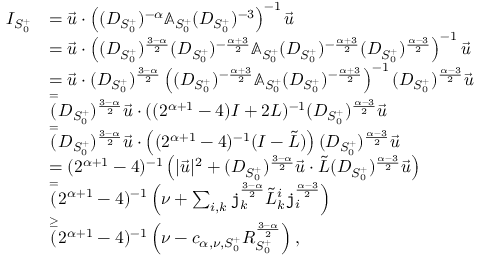<formula> <loc_0><loc_0><loc_500><loc_500>\begin{array} { r l } { I _ { S _ { 0 } ^ { + } } } & { = \vec { u } \cdot \left ( ( D _ { S _ { 0 } ^ { + } } ) ^ { - \alpha } \mathbb { A } _ { S _ { 0 } ^ { + } } ( D _ { S _ { 0 } ^ { + } } ) ^ { - 3 } \right ) ^ { - 1 } \vec { u } } \\ & { = \vec { u } \cdot \left ( ( D _ { S _ { 0 } ^ { + } } ) ^ { \frac { 3 - \alpha } 2 } ( D _ { S _ { 0 } ^ { + } } ) ^ { - \frac { \alpha + 3 } { 2 } } \mathbb { A } _ { S _ { 0 } ^ { + } } ( D _ { S _ { 0 } ^ { + } } ) ^ { - \frac { \alpha + 3 } 2 } ( D _ { S _ { 0 } ^ { + } } ) ^ { \frac { \alpha - 3 } 2 } \right ) ^ { - 1 } \vec { u } } \\ & { = \vec { u } \cdot ( D _ { S _ { 0 } ^ { + } } ) ^ { \frac { 3 - \alpha } 2 } \left ( ( D _ { S _ { 0 } ^ { + } } ) ^ { - \frac { \alpha + 3 } { 2 } } \mathbb { A } _ { S _ { 0 } ^ { + } } ( D _ { S _ { 0 } ^ { + } } ) ^ { - \frac { \alpha + 3 } 2 } \right ) ^ { - 1 } ( D _ { S _ { 0 } ^ { + } } ) ^ { \frac { \alpha - 3 } 2 } \vec { u } } \\ & { \overset { = } { ( } D _ { S _ { 0 } ^ { + } } ) ^ { \frac { 3 - \alpha } 2 } \vec { u } \cdot ( ( 2 ^ { \alpha + 1 } - 4 ) I + 2 L ) ^ { - 1 } ( D _ { S _ { 0 } ^ { + } } ) ^ { \frac { \alpha - 3 } 2 } \vec { u } } \\ & { \overset { = } { ( } D _ { S _ { 0 } ^ { + } } ) ^ { \frac { 3 - \alpha } 2 } \vec { u } \cdot \left ( ( 2 ^ { \alpha + 1 } - 4 ) ^ { - 1 } ( I - \tilde { L } ) \right ) ( D _ { S _ { 0 } ^ { + } } ) ^ { \frac { \alpha - 3 } 2 } \vec { u } } \\ & { = ( 2 ^ { \alpha + 1 } - 4 ) ^ { - 1 } \left ( | \vec { u } | ^ { 2 } + ( D _ { S _ { 0 } ^ { + } } ) ^ { \frac { 3 - \alpha } 2 } \vec { u } \cdot \tilde { L } ( D _ { S _ { 0 } ^ { + } } ) ^ { \frac { \alpha - 3 } 2 } \vec { u } \right ) } \\ & { \overset { = } { ( } 2 ^ { \alpha + 1 } - 4 ) ^ { - 1 } \left ( \nu + \sum _ { i , k } j _ { k } ^ { \frac { 3 - \alpha } 2 } \tilde { L } _ { k } ^ { i } j _ { i } ^ { \frac { \alpha - 3 } 2 } \right ) } \\ & { \overset { \geq } { ( } 2 ^ { \alpha + 1 } - 4 ) ^ { - 1 } \left ( \nu - c _ { \alpha , \nu , S _ { 0 } ^ { + } } R _ { S _ { 0 } ^ { + } } ^ { \frac { 3 - \alpha } 2 } \right ) , } \end{array}</formula> 